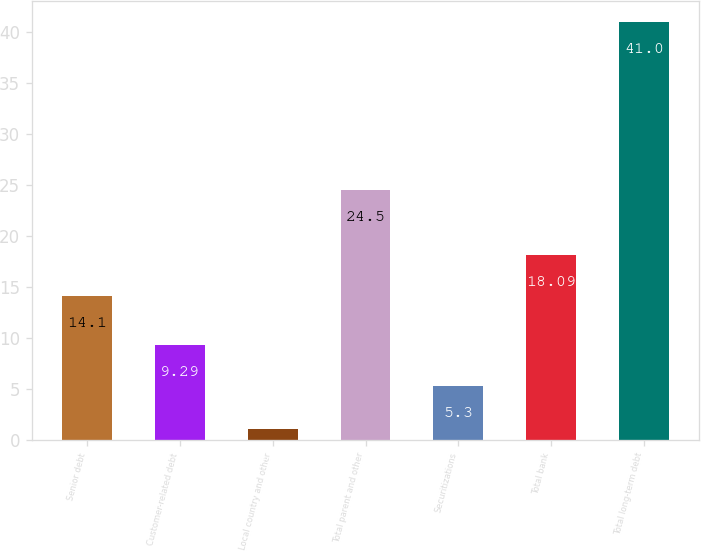Convert chart. <chart><loc_0><loc_0><loc_500><loc_500><bar_chart><fcel>Senior debt<fcel>Customer-related debt<fcel>Local country and other<fcel>Total parent and other<fcel>Securitizations<fcel>Total bank<fcel>Total long-term debt<nl><fcel>14.1<fcel>9.29<fcel>1.1<fcel>24.5<fcel>5.3<fcel>18.09<fcel>41<nl></chart> 